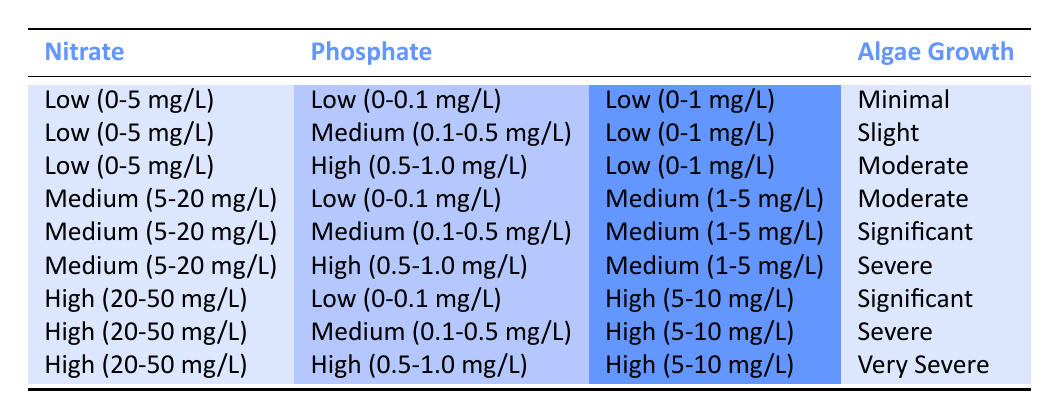What is the algae growth when nitrate and phosphate levels are both low? The table shows that when nitrate is low (0-5 mg/L) and phosphate is low (0-0.1 mg/L), the algae growth is minimal.
Answer: Minimal How does algae growth change with increasing phosphate levels while nitrate is kept low? When nitrate is kept low (0-5 mg/L) and phosphate levels increase from low (0-0.1 mg/L) to medium (0.1-0.5 mg/L) and then high (0.5-1.0 mg/L), the algae growth progresses from minimal to slight, and then to moderate, indicating a positive correlation with phosphate levels.
Answer: Minimal to slight to moderate Is algae growth severe when nitrate levels are high and phosphate levels are low? According to the table, when nitrate is high (20-50 mg/L) and phosphate is low (0-0.1 mg/L), the algae growth is significant, not severe. Therefore, the answer is no.
Answer: No What nutrient combination results in very severe algae growth? The table indicates that very severe algae growth occurs when nitrate is high (20-50 mg/L), phosphate is high (0.5-1.0 mg/L), and silicate is high (5-10 mg/L).
Answer: High nitrate, high phosphate, high silicate If silicate is medium (1-5 mg/L), what is the highest algae growth that can be observed? From the table, for silicate at medium levels (1-5 mg/L), the highest observed algae growth is severe; this occurs with medium nitrate and high phosphate or with high nitrate and medium phosphate levels.
Answer: Severe Does moderate algae growth occur with a phosphate level higher than 0.1 mg/L? Yes, moderate algae growth is observed when phosphate is high (0.5-1.0 mg/L) with low nitrate (0-5 mg/L). Thus, the statement is true.
Answer: Yes How many different algae growth levels are shown in the table? The table lists five distinct algae growth levels: minimal, slight, moderate, significant, severe, and very severe, making a total of six.
Answer: Six What is the growth level when nitrate is low, phosphate is medium, and silicate is low? Referring to the table, when nitrate is low (0-5 mg/L), phosphate is medium (0.1-0.5 mg/L), and silicate is low (0-1 mg/L), the algae growth is slight.
Answer: Slight If the silicate level is high, what are the corresponding nitrate and phosphate levels associated with the severe growth? For the severe growth level with high silicate (5-10 mg/L), nitrate can either be high (20-50 mg/L) with medium phosphate or medium (5-20 mg/L) with high phosphate.
Answer: High nitrate, medium phosphate or Medium nitrate, high phosphate 